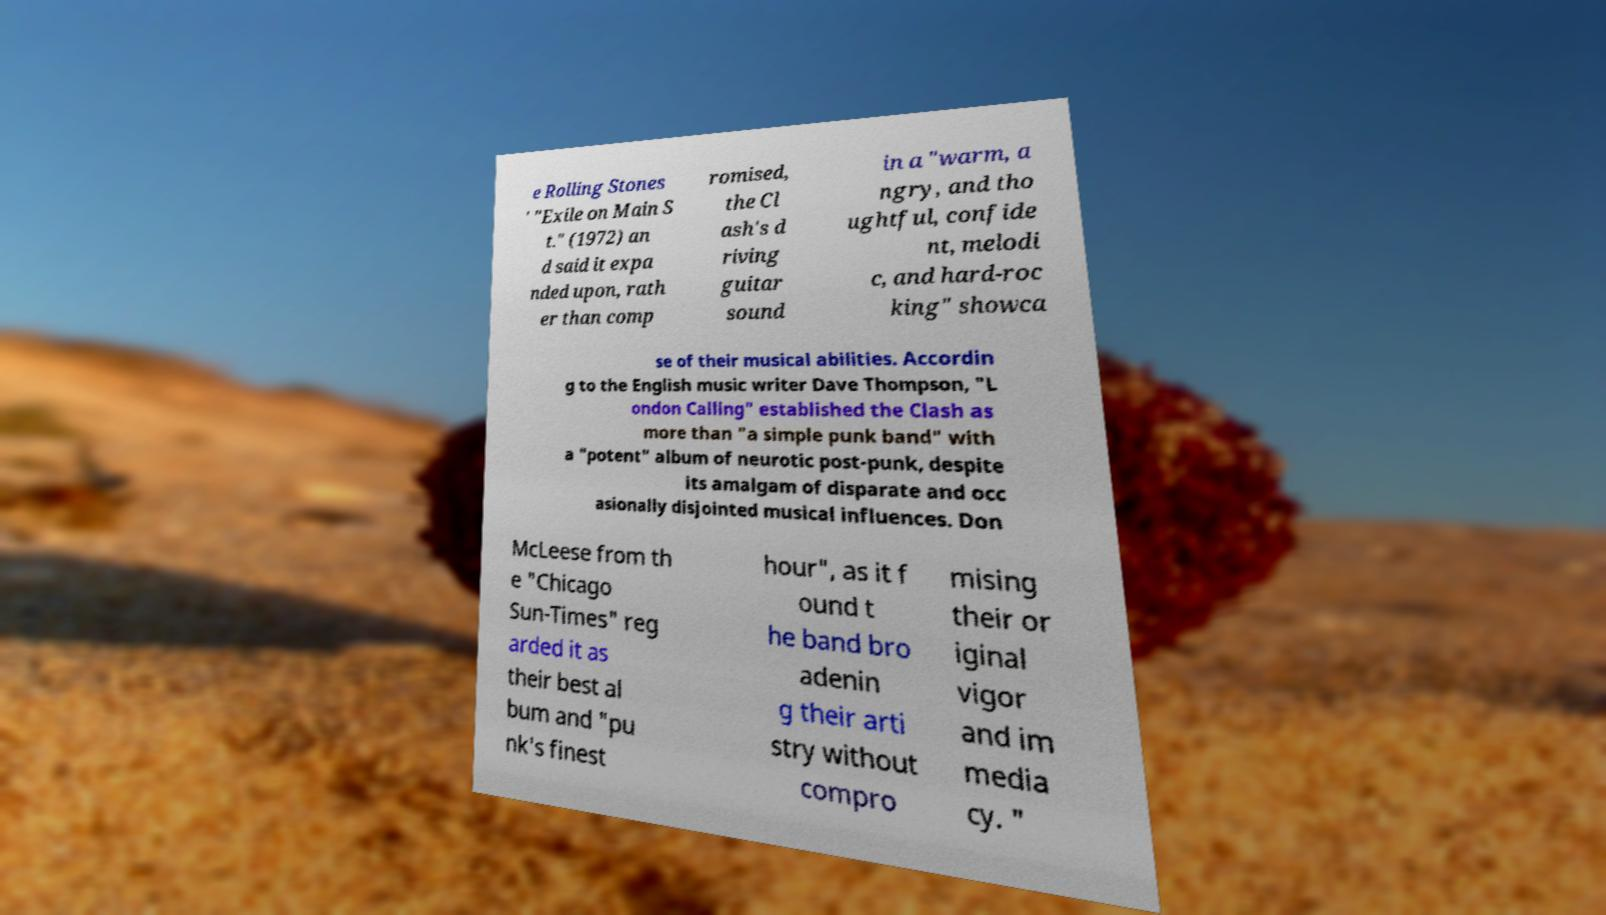There's text embedded in this image that I need extracted. Can you transcribe it verbatim? e Rolling Stones ' "Exile on Main S t." (1972) an d said it expa nded upon, rath er than comp romised, the Cl ash's d riving guitar sound in a "warm, a ngry, and tho ughtful, confide nt, melodi c, and hard-roc king" showca se of their musical abilities. Accordin g to the English music writer Dave Thompson, "L ondon Calling" established the Clash as more than "a simple punk band" with a "potent" album of neurotic post-punk, despite its amalgam of disparate and occ asionally disjointed musical influences. Don McLeese from th e "Chicago Sun-Times" reg arded it as their best al bum and "pu nk's finest hour", as it f ound t he band bro adenin g their arti stry without compro mising their or iginal vigor and im media cy. " 